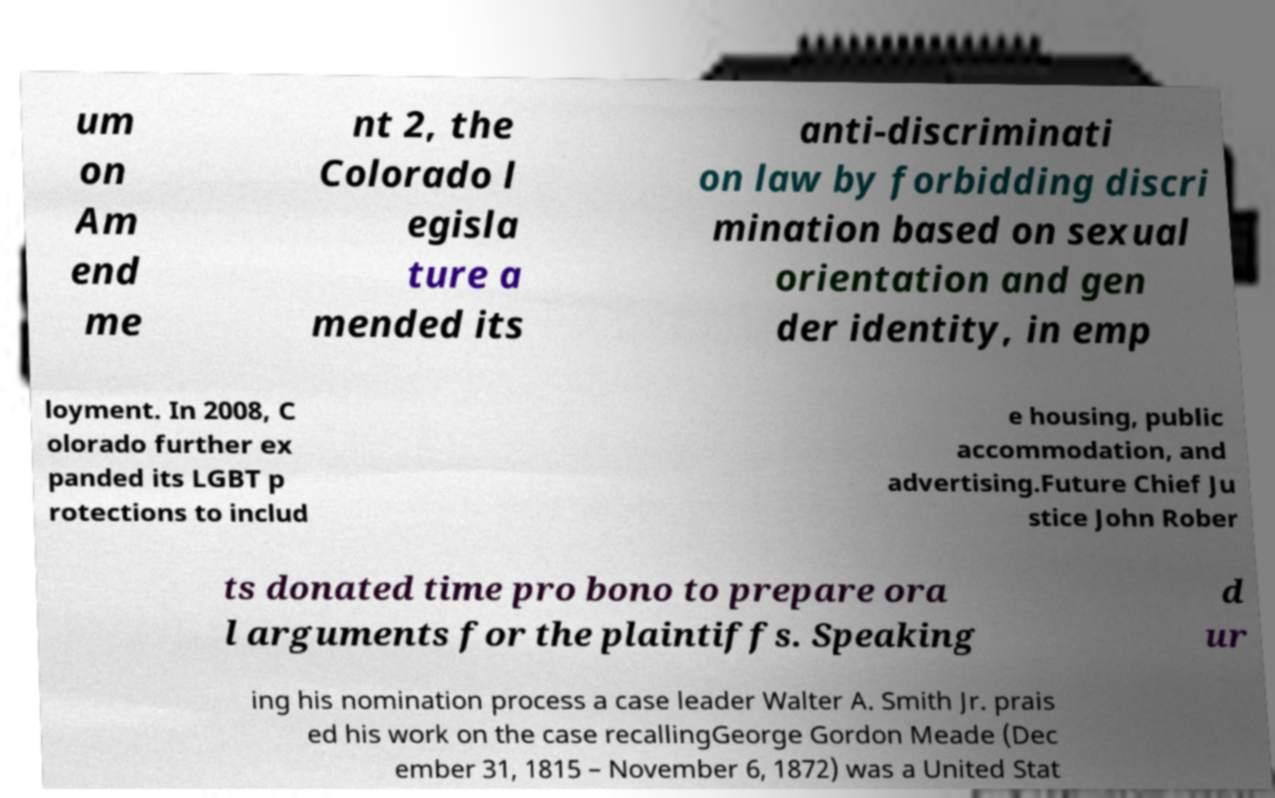Please read and relay the text visible in this image. What does it say? um on Am end me nt 2, the Colorado l egisla ture a mended its anti-discriminati on law by forbidding discri mination based on sexual orientation and gen der identity, in emp loyment. In 2008, C olorado further ex panded its LGBT p rotections to includ e housing, public accommodation, and advertising.Future Chief Ju stice John Rober ts donated time pro bono to prepare ora l arguments for the plaintiffs. Speaking d ur ing his nomination process a case leader Walter A. Smith Jr. prais ed his work on the case recallingGeorge Gordon Meade (Dec ember 31, 1815 – November 6, 1872) was a United Stat 